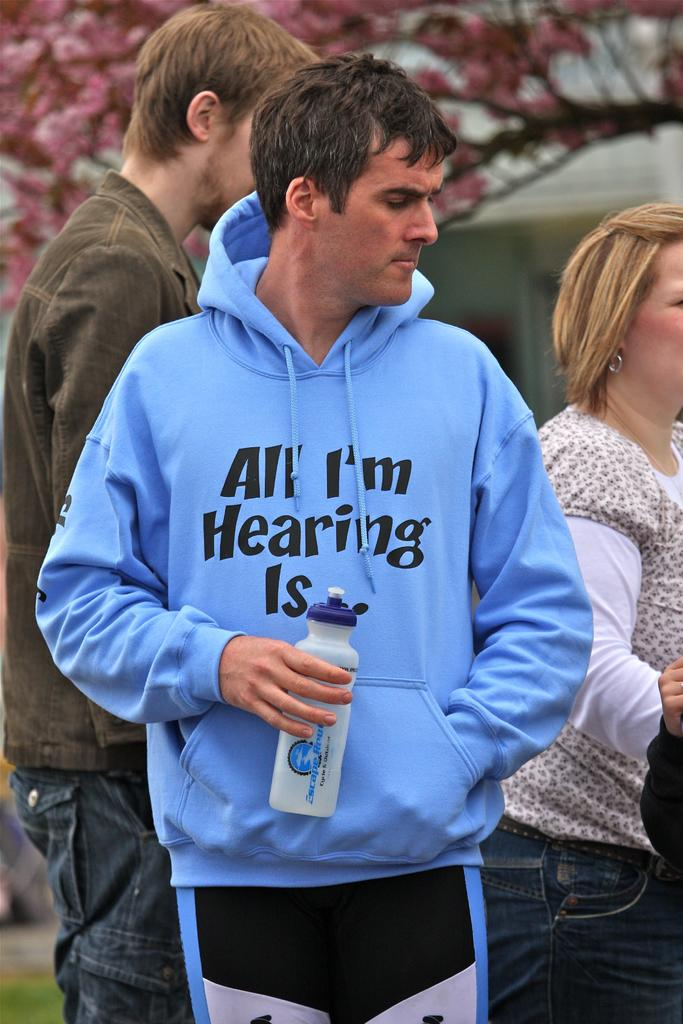How many people are in the image? There are three people in the image. Can you describe the clothing of one of the individuals? One person is wearing a blue jacket. What is the person wearing the blue jacket holding? The person with the blue jacket is holding a bottle. What can be seen in the distance behind the people? There is a tree visible in the background of the image. What type of popcorn is being served in the image? There is no popcorn present in the image. Is there a cabbage growing near the tree in the background? There is no cabbage visible in the image; only a tree can be seen in the background. 